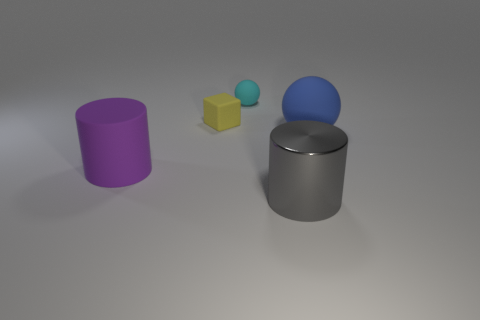What number of other things are the same size as the yellow object?
Ensure brevity in your answer.  1. Is the material of the big thing that is behind the purple object the same as the gray thing?
Offer a terse response. No. What number of other things are there of the same color as the tiny matte cube?
Keep it short and to the point. 0. What number of other things are there of the same shape as the large blue matte thing?
Ensure brevity in your answer.  1. There is a thing that is right of the big gray metallic thing; is it the same shape as the tiny cyan matte thing that is behind the big gray object?
Give a very brief answer. Yes. Are there the same number of purple objects in front of the shiny cylinder and big cylinders that are to the right of the purple object?
Your answer should be compact. No. What is the shape of the large matte object behind the cylinder on the left side of the small object that is left of the cyan sphere?
Provide a succinct answer. Sphere. Are the big thing left of the large gray metal object and the cylinder that is to the right of the small block made of the same material?
Ensure brevity in your answer.  No. What shape is the large rubber object on the left side of the blue sphere?
Make the answer very short. Cylinder. Is the number of big blue matte spheres less than the number of big brown metal blocks?
Ensure brevity in your answer.  No. 